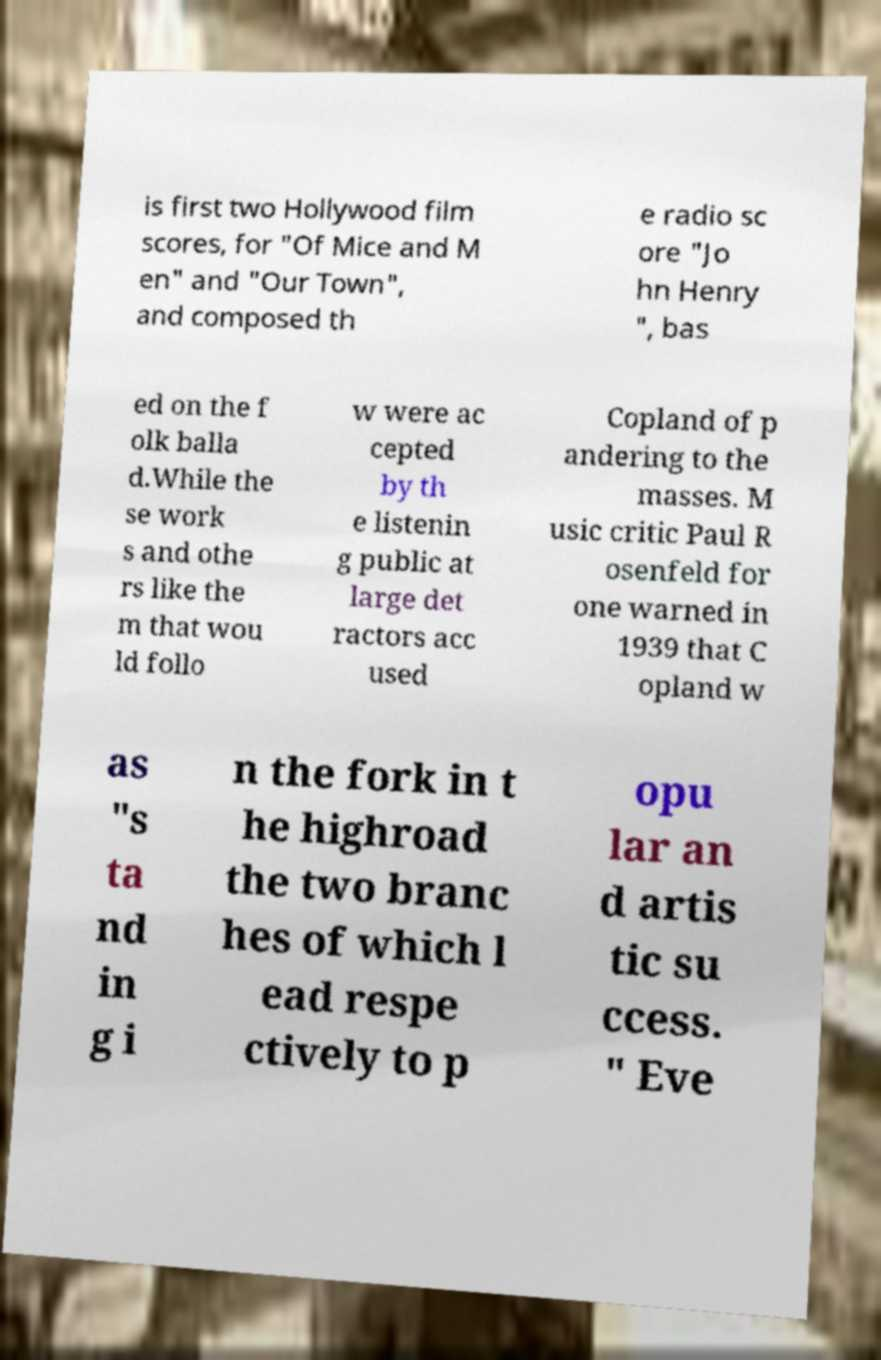Can you read and provide the text displayed in the image?This photo seems to have some interesting text. Can you extract and type it out for me? is first two Hollywood film scores, for "Of Mice and M en" and "Our Town", and composed th e radio sc ore "Jo hn Henry ", bas ed on the f olk balla d.While the se work s and othe rs like the m that wou ld follo w were ac cepted by th e listenin g public at large det ractors acc used Copland of p andering to the masses. M usic critic Paul R osenfeld for one warned in 1939 that C opland w as "s ta nd in g i n the fork in t he highroad the two branc hes of which l ead respe ctively to p opu lar an d artis tic su ccess. " Eve 